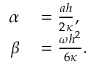Convert formula to latex. <formula><loc_0><loc_0><loc_500><loc_500>\begin{array} { r l } { \alpha } & = \frac { a h } { 2 \kappa } , } \\ { \beta } & = \frac { \omega h ^ { 2 } } { 6 \kappa } . } \end{array}</formula> 